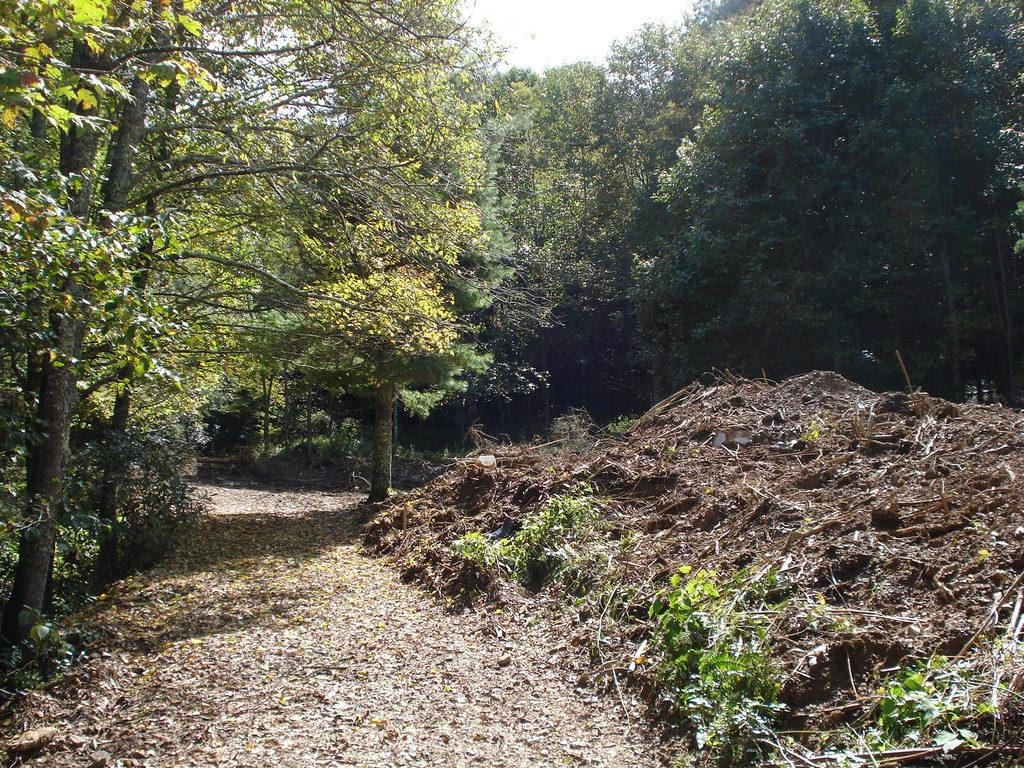What is in the center of the image? There is a road with dry leaves in the center of the image. What can be seen in the background of the image? There are trees in the background of the image. What type of spade is being used to balance the leaves in the image? There is no spade or balancing act involving leaves in the image. 